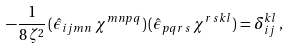<formula> <loc_0><loc_0><loc_500><loc_500>- \frac { 1 } { 8 \, \zeta ^ { 2 } } \, ( { \hat { \epsilon } } _ { i j m n } \, \chi ^ { m n p q } ) \, ( { \hat { \epsilon } } _ { p q r \, s } \, \chi ^ { r \, s k l } ) = \delta ^ { k l } _ { i j } \, ,</formula> 